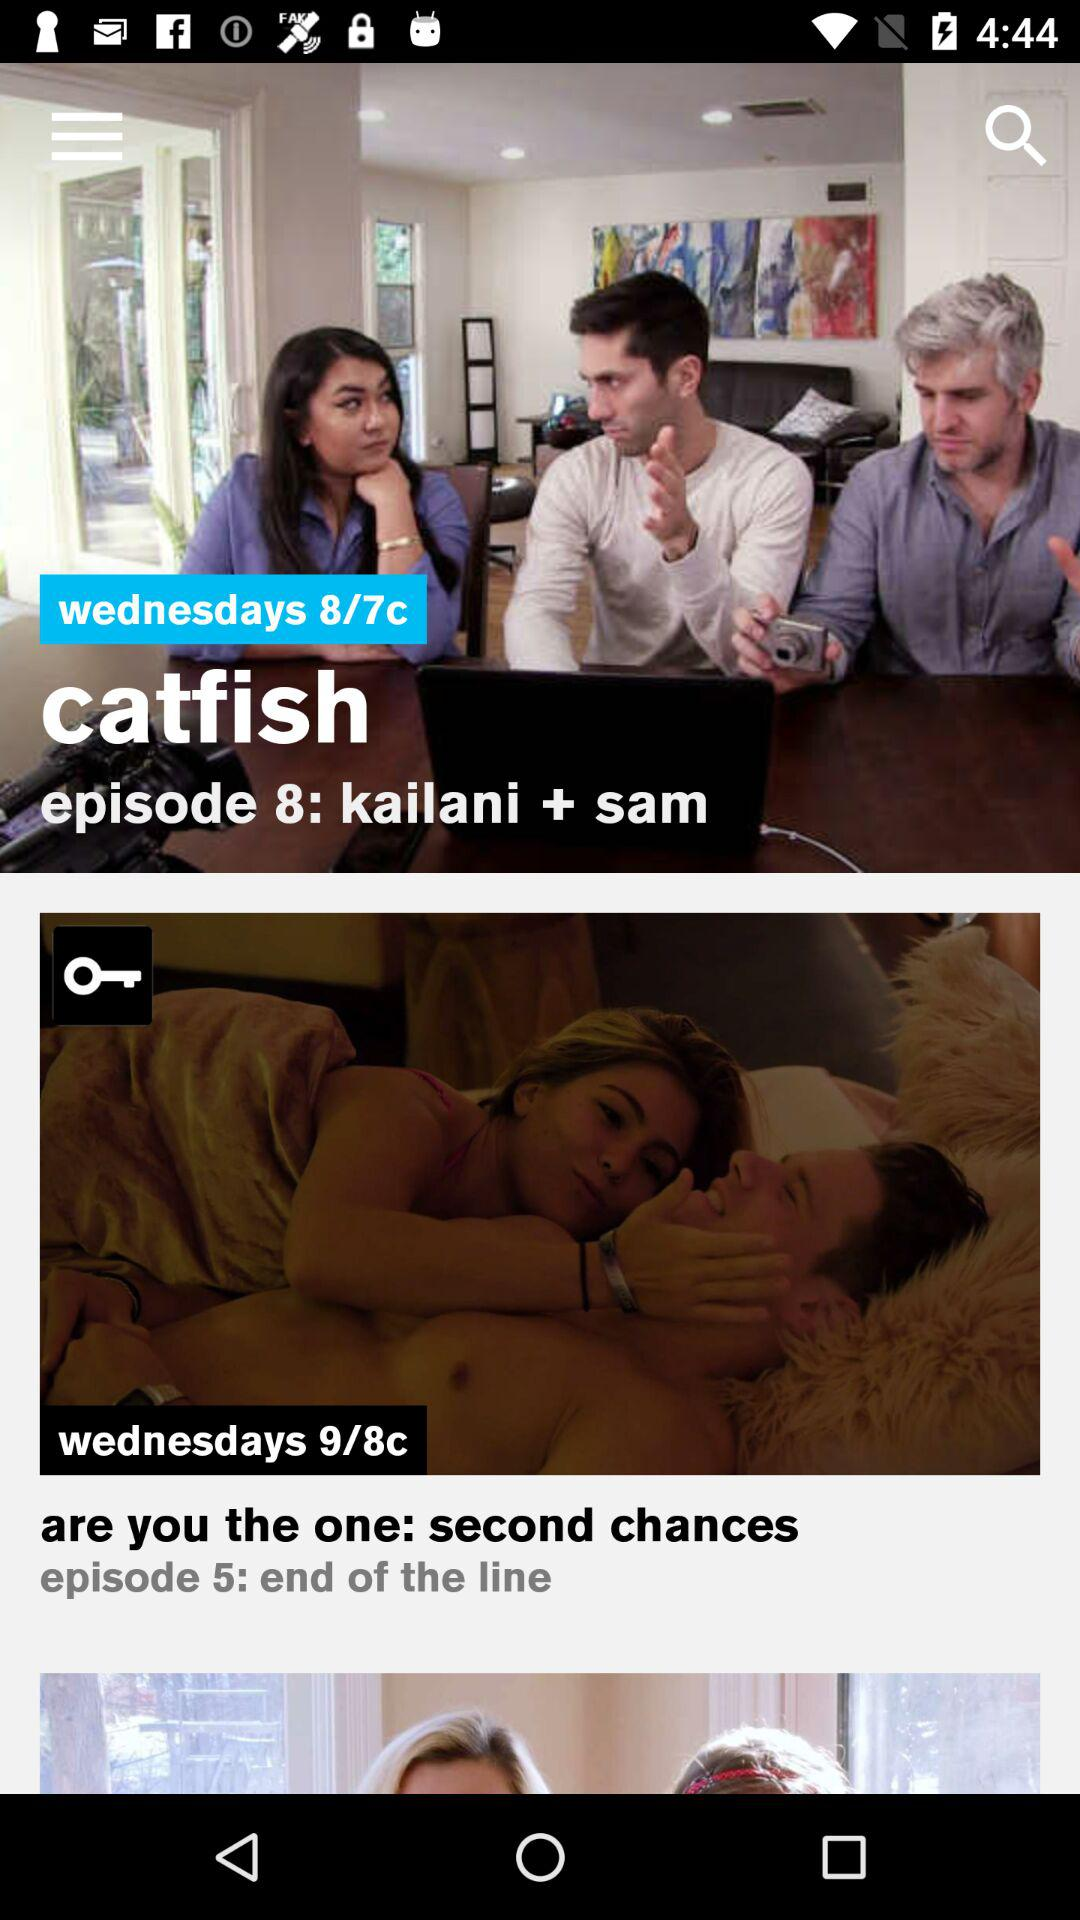What are the names of the TV shows? The names of the TV shows are "catfish" and "are you the one: second chances". 